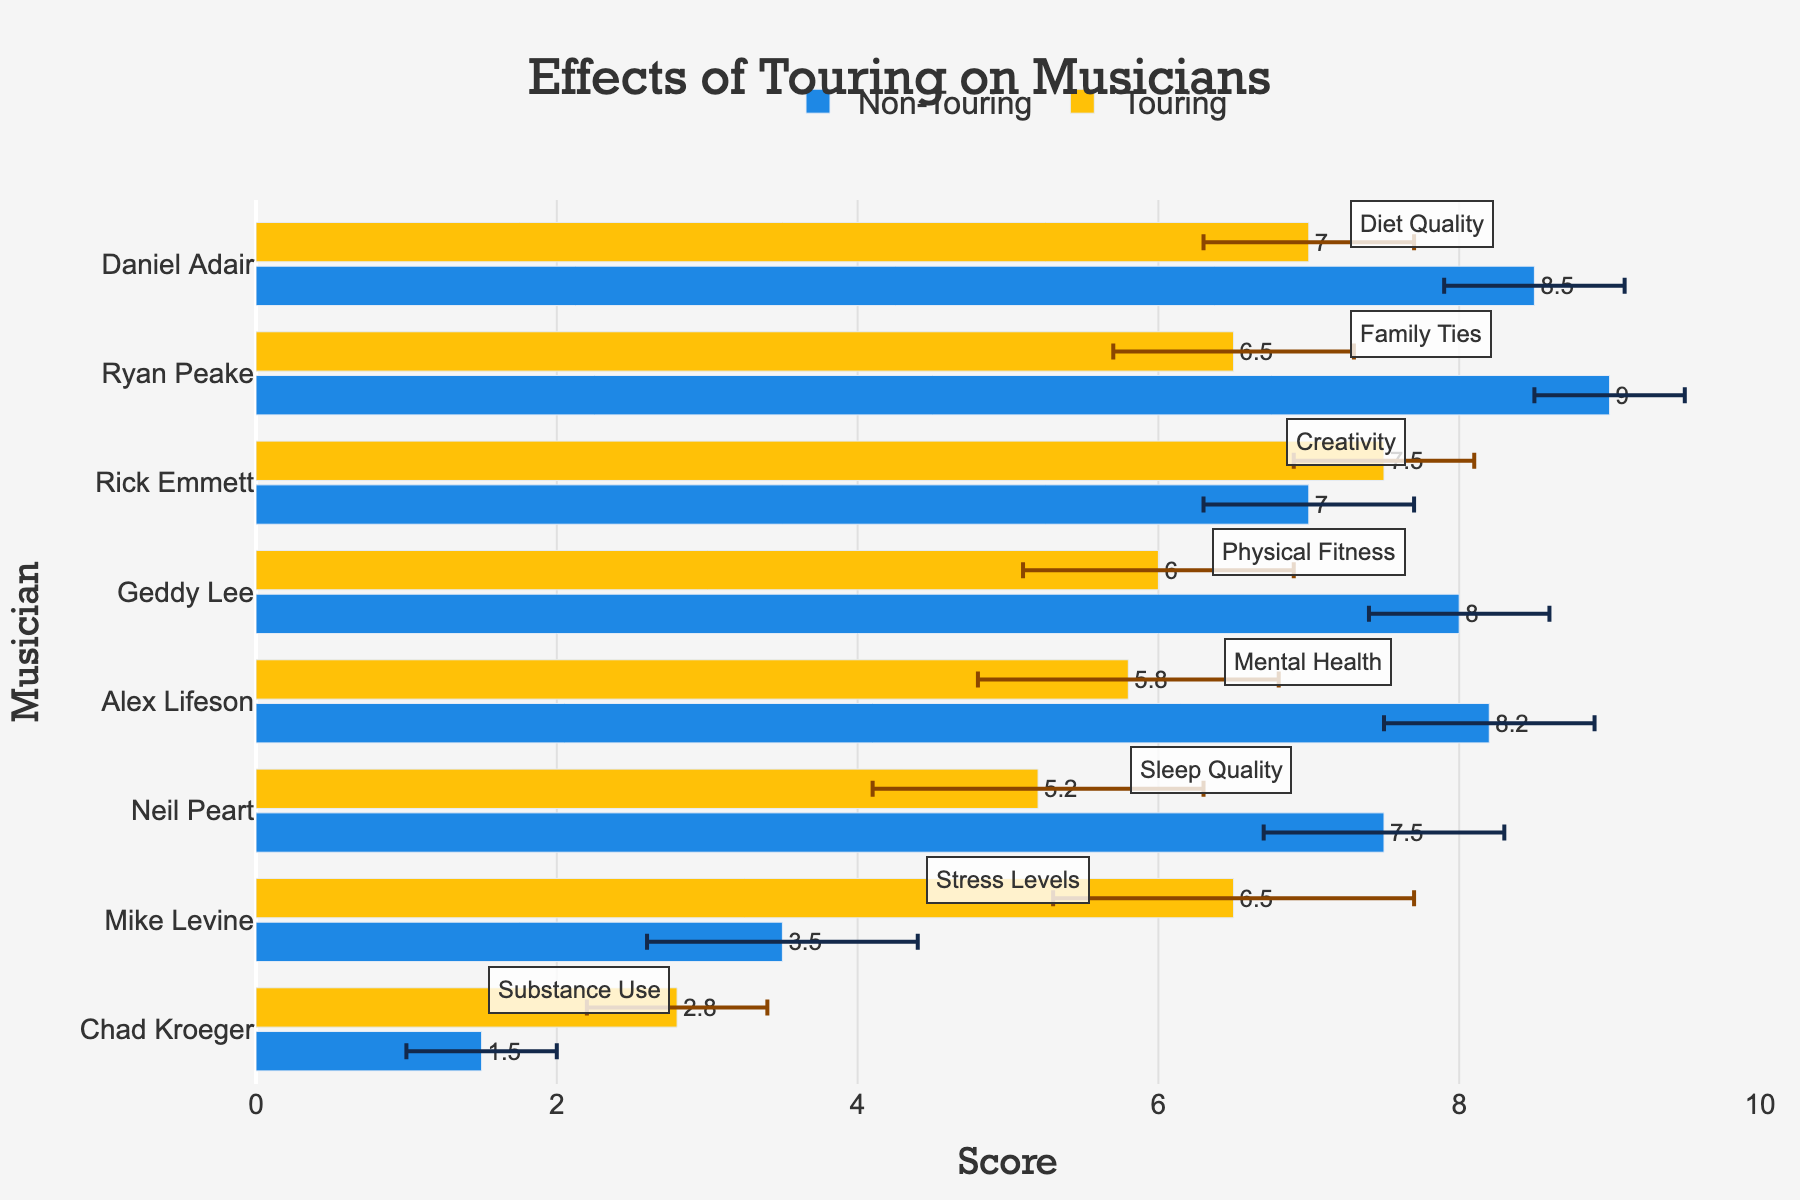What's the difference in sleep quality for Neil Peart between touring and non-touring periods? Find the values for sleep quality during non-touring and touring periods for Neil Peart. Subtract the touring value (5.2) from the non-touring value (7.5). 7.5 - 5.2 is 2.3.
Answer: 2.3 Which musician has the largest decline in physical fitness when touring? Check the physical fitness scores for all musicians during non-touring and touring periods, and find the largest difference. Geddy Lee has physical fitness scores of 8.0 during non-touring and 6.0 during touring, the largest decline of 2.
Answer: Geddy Lee What is the average mental health score for Alex Lifeson in both periods? Add the mental health scores for Alex Lifeson during non-touring (8.2) and touring (5.8), then divide by 2. (8.2 + 5.8) / 2 = 7.
Answer: 7 Who experiences an increase in creativity during touring? Compare the creativity scores during non-touring and touring periods for each musician. Rick Emmett's creativity score increases from 7.0 during non-touring to 7.5 during touring.
Answer: Rick Emmett Which musician has the smallest difference in diet quality between touring and non-touring periods? Find the difference in diet quality scores for each musician and identify the smallest one. Daniel Adair has a difference of 1.5 (8.5 during non-touring and 7.0 during touring).
Answer: Daniel Adair What is the sum of family ties scores for Ryan Peake in both periods? Add the family ties scores during non-touring (9.0) and touring (6.5) for Ryan Peake. 9.0 + 6.5 = 15.5.
Answer: 15.5 Which measure shows the greatest decline for Alex Lifeson when touring? Compare all measures (sleep quality, physical fitness, mental health, substance use, family ties, diet quality, stress levels, creativity) for Alex Lifeson and identify the greatest decline. Mental health declines the most, from 8.2 to 5.8.
Answer: Mental health Does anyone have better physical fitness while touring than Geddy Lee's non-touring score? Compare all musicians' physical fitness scores during touring with Geddy Lee’s non-touring score (8.0). None exceed it.
Answer: No 